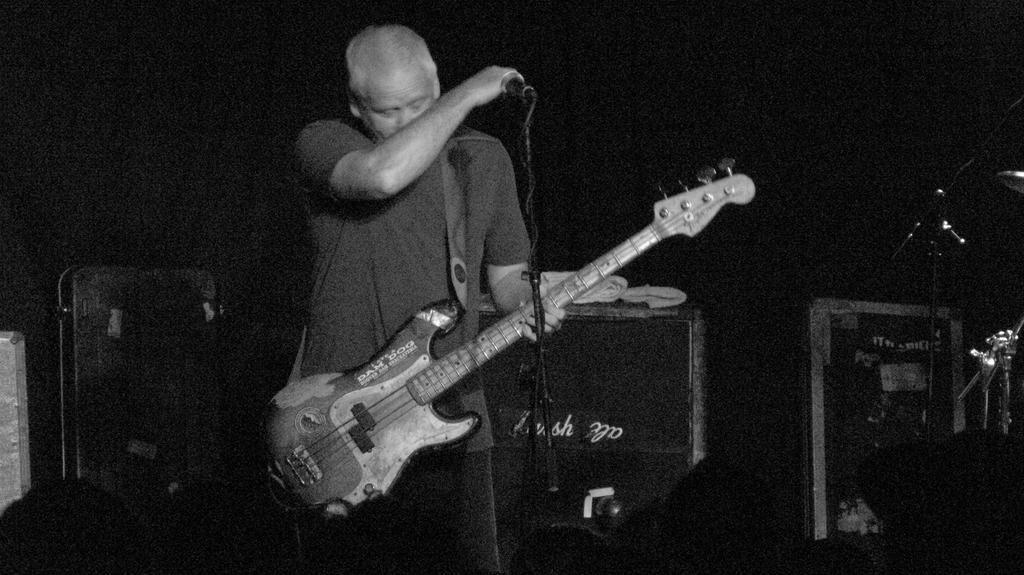How would you summarize this image in a sentence or two? A man holding a guitar. In front of him there is a mic and mic stand. In the background there are many other items. 